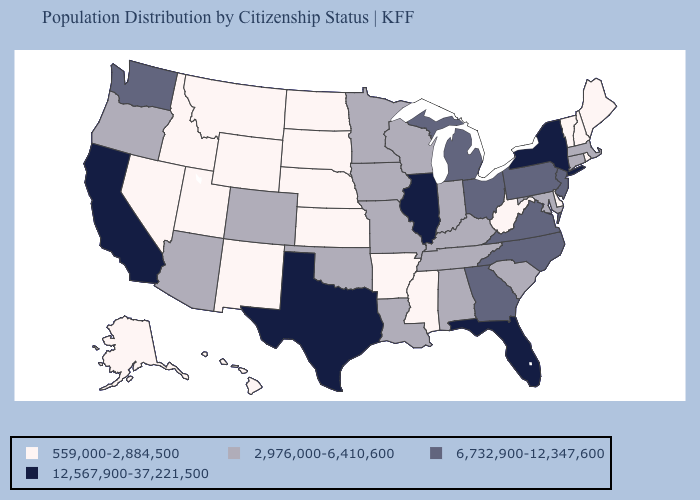Does Utah have the lowest value in the USA?
Answer briefly. Yes. Does Washington have the lowest value in the West?
Answer briefly. No. What is the value of Missouri?
Be succinct. 2,976,000-6,410,600. What is the highest value in the USA?
Quick response, please. 12,567,900-37,221,500. Name the states that have a value in the range 2,976,000-6,410,600?
Concise answer only. Alabama, Arizona, Colorado, Connecticut, Indiana, Iowa, Kentucky, Louisiana, Maryland, Massachusetts, Minnesota, Missouri, Oklahoma, Oregon, South Carolina, Tennessee, Wisconsin. Among the states that border Kentucky , does West Virginia have the lowest value?
Write a very short answer. Yes. Among the states that border New Mexico , which have the highest value?
Answer briefly. Texas. What is the highest value in states that border Illinois?
Give a very brief answer. 2,976,000-6,410,600. Name the states that have a value in the range 6,732,900-12,347,600?
Concise answer only. Georgia, Michigan, New Jersey, North Carolina, Ohio, Pennsylvania, Virginia, Washington. Does Vermont have a higher value than Idaho?
Answer briefly. No. Which states have the lowest value in the West?
Quick response, please. Alaska, Hawaii, Idaho, Montana, Nevada, New Mexico, Utah, Wyoming. What is the highest value in the USA?
Give a very brief answer. 12,567,900-37,221,500. Among the states that border Arizona , which have the lowest value?
Answer briefly. Nevada, New Mexico, Utah. What is the highest value in the USA?
Give a very brief answer. 12,567,900-37,221,500. What is the value of Idaho?
Be succinct. 559,000-2,884,500. 